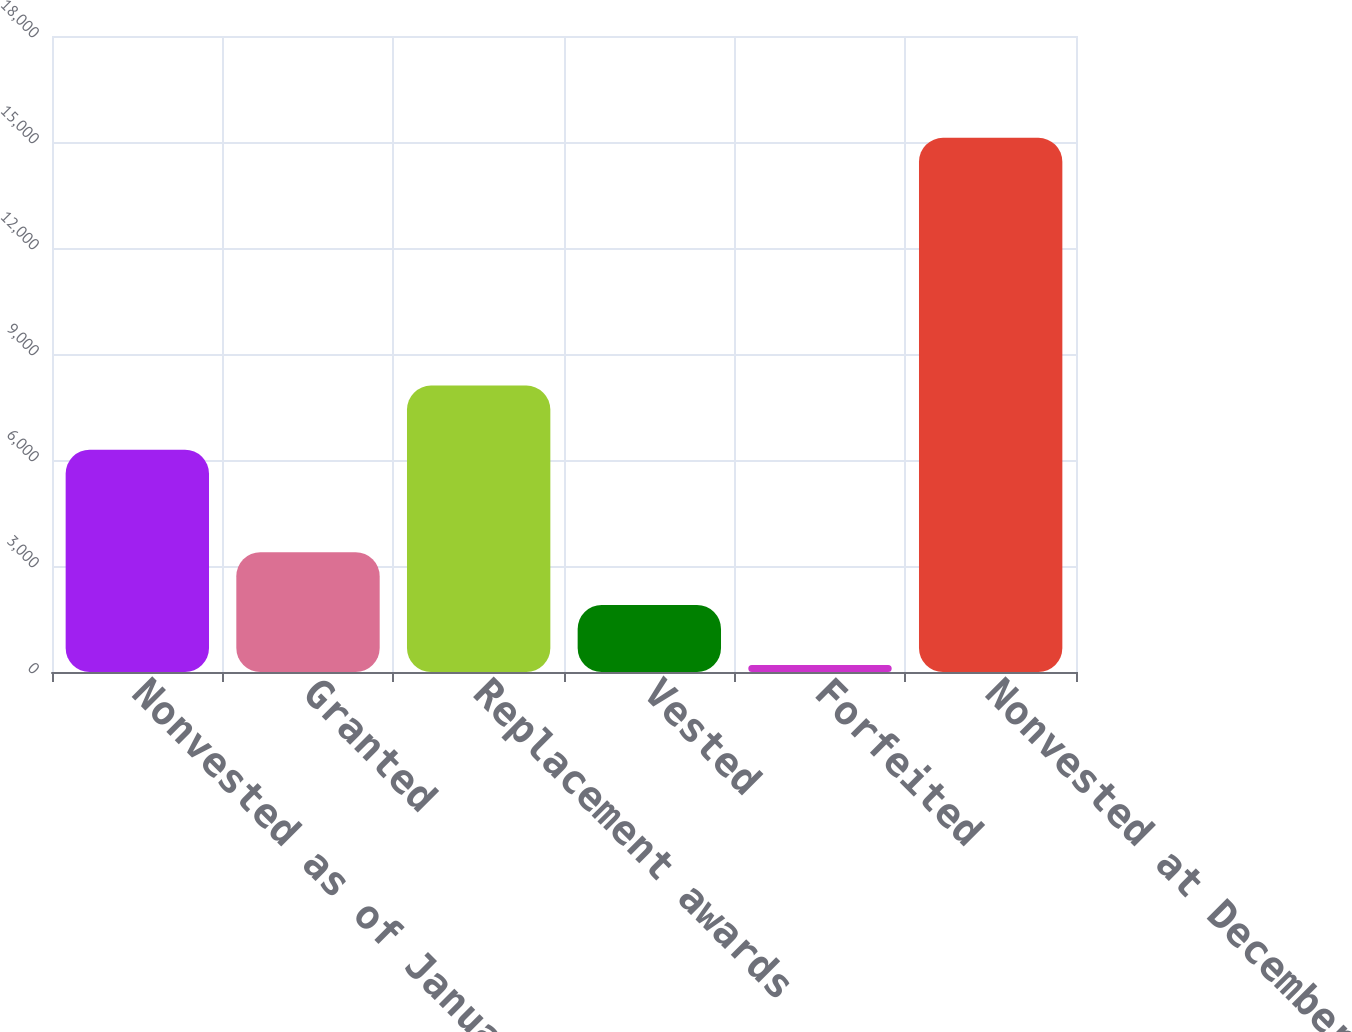<chart> <loc_0><loc_0><loc_500><loc_500><bar_chart><fcel>Nonvested as of January 1 2009<fcel>Granted<fcel>Replacement awards<fcel>Vested<fcel>Forfeited<fcel>Nonvested at December 31 2009<nl><fcel>6292.2<fcel>3388.37<fcel>8105.6<fcel>1896.6<fcel>201<fcel>15118.7<nl></chart> 